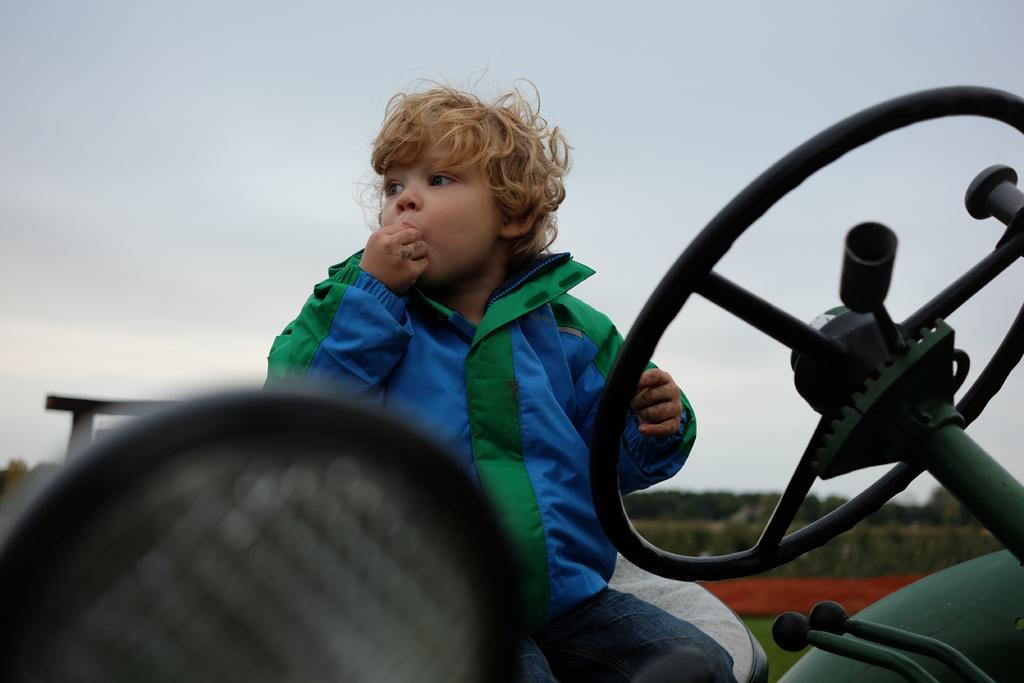Who is the main subject in the image? There is a boy in the image. What is a distinctive feature of the boy's appearance? The boy has golden hair. What is the boy wearing in the image? The boy is wearing a jacket with green and blue colors. In which direction is the boy looking? The boy is looking to his right side. Where is the image located? The image is part of a vehicle. What is the color of the sky in the image? The sky is pale blue in color. What type of breakfast is the boy eating in the image? There is no breakfast visible in the image; the boy is not eating anything. What type of rhythm is the boy tapping out on the vehicle's dashboard? There is no indication in the image that the boy is tapping out a rhythm or interacting with the vehicle's dashboard. 